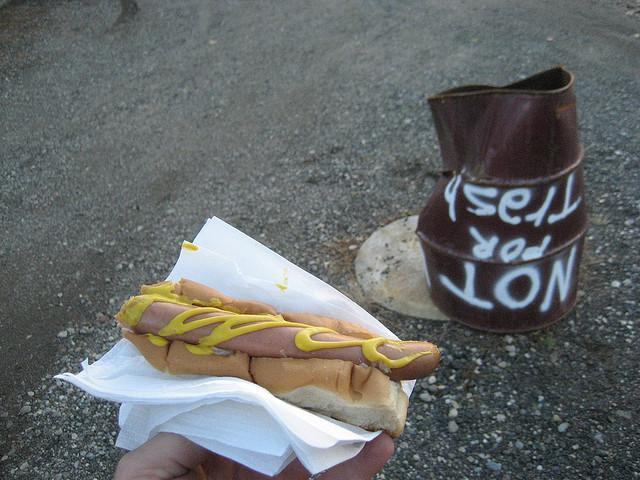How many black dogs are on front front a woman?
Give a very brief answer. 0. 